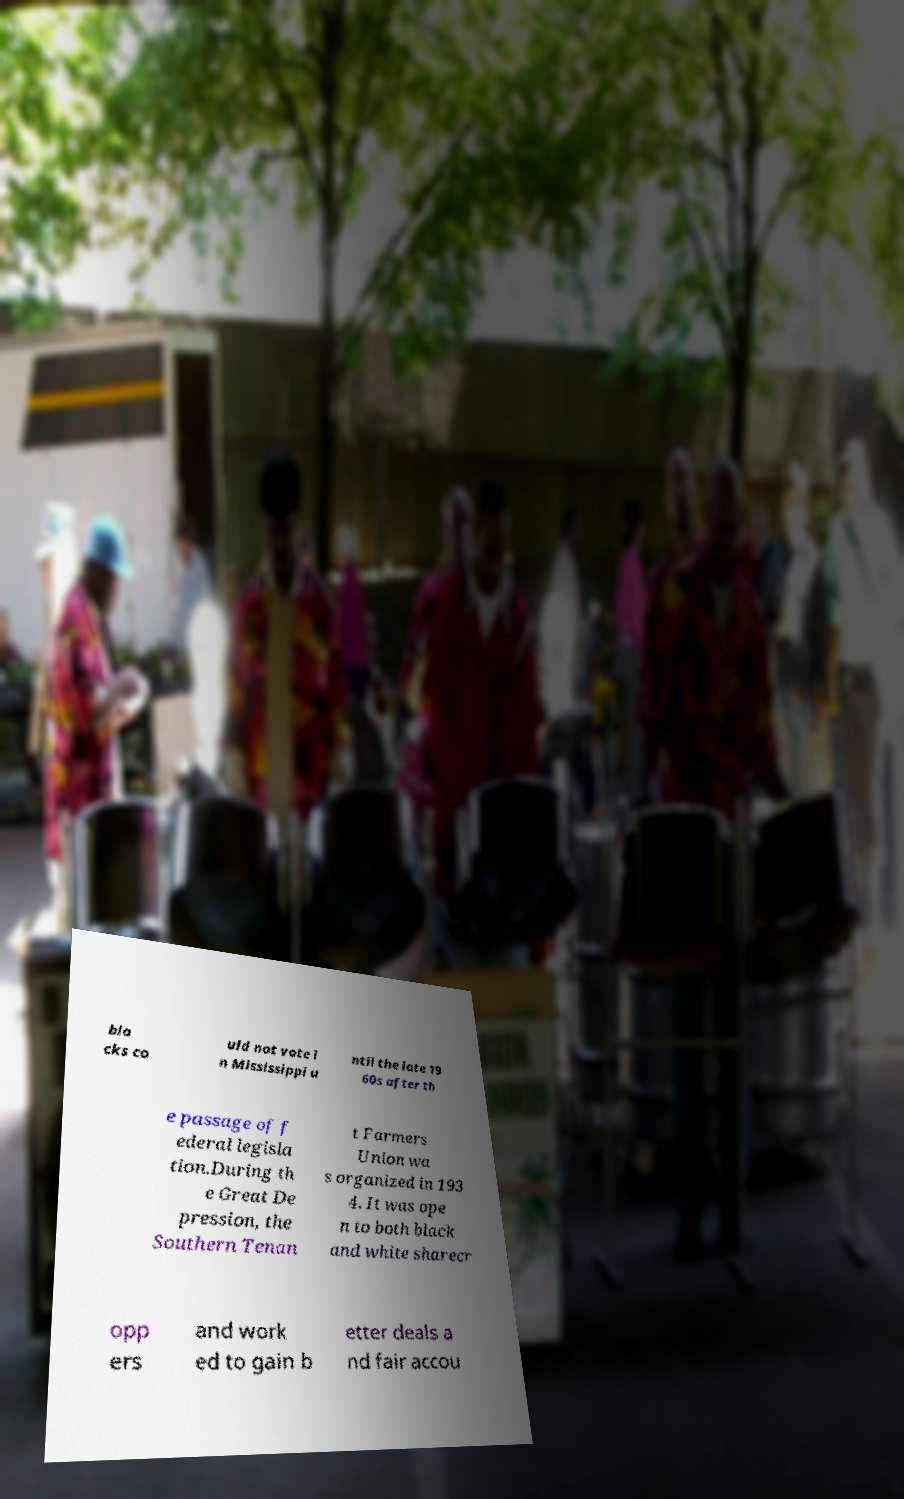Could you assist in decoding the text presented in this image and type it out clearly? bla cks co uld not vote i n Mississippi u ntil the late 19 60s after th e passage of f ederal legisla tion.During th e Great De pression, the Southern Tenan t Farmers Union wa s organized in 193 4. It was ope n to both black and white sharecr opp ers and work ed to gain b etter deals a nd fair accou 